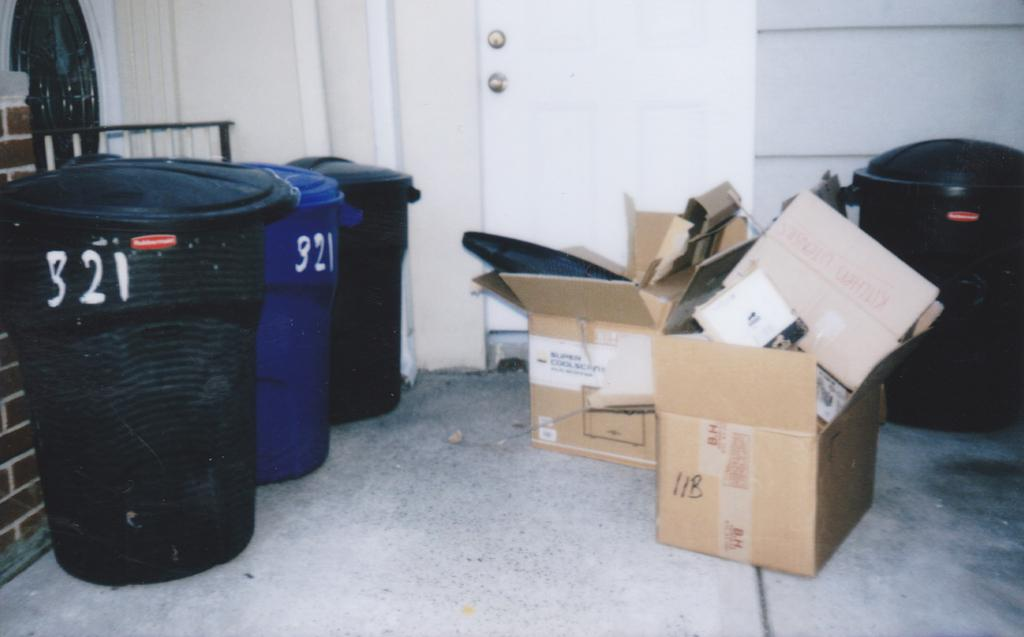What type of containers are present in the image? There are bins in the image. What colors are the bins? The bins are black and blue. What other objects can be seen in the image? There are cardboard boxes in the image. What color is the wall in the image? The wall in the image is white. What type of furniture is being used for sleeping in the image? There is no furniture or indication of sleeping in the image; it primarily features bins and cardboard boxes. 